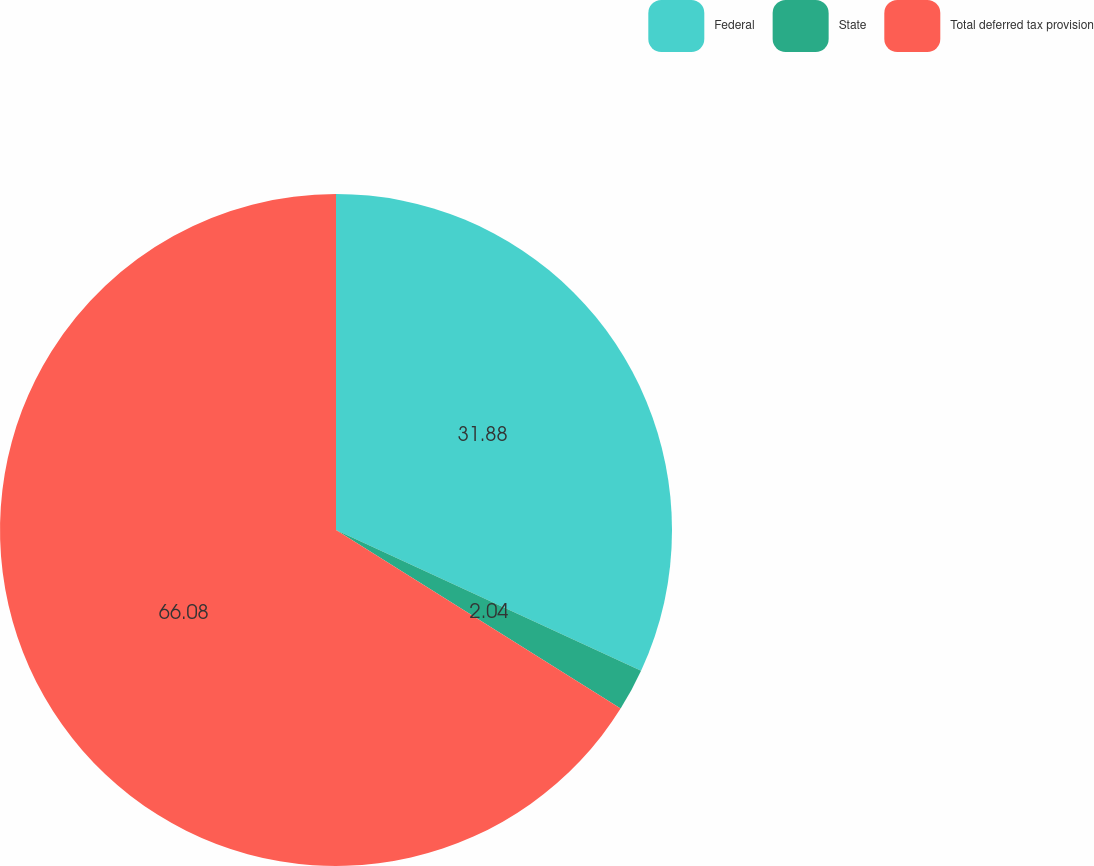Convert chart to OTSL. <chart><loc_0><loc_0><loc_500><loc_500><pie_chart><fcel>Federal<fcel>State<fcel>Total deferred tax provision<nl><fcel>31.88%<fcel>2.04%<fcel>66.08%<nl></chart> 